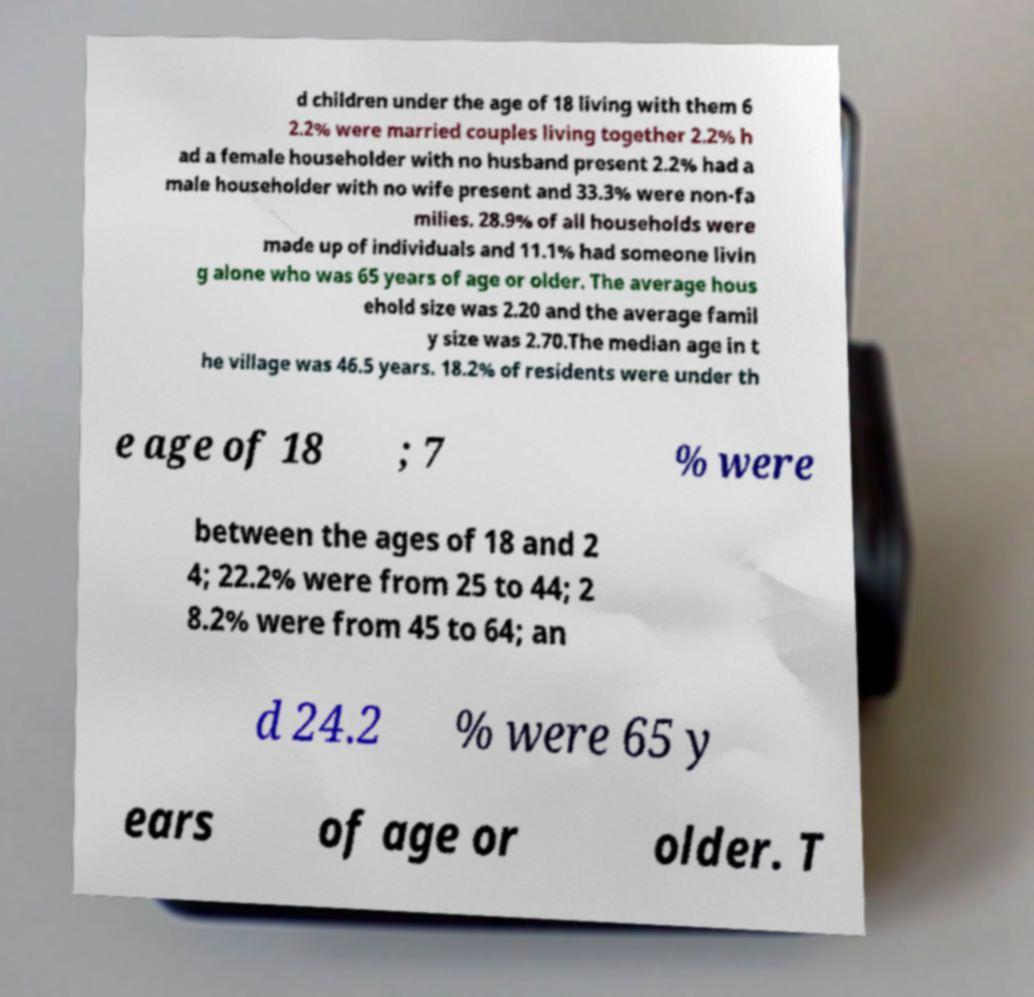What messages or text are displayed in this image? I need them in a readable, typed format. d children under the age of 18 living with them 6 2.2% were married couples living together 2.2% h ad a female householder with no husband present 2.2% had a male householder with no wife present and 33.3% were non-fa milies. 28.9% of all households were made up of individuals and 11.1% had someone livin g alone who was 65 years of age or older. The average hous ehold size was 2.20 and the average famil y size was 2.70.The median age in t he village was 46.5 years. 18.2% of residents were under th e age of 18 ; 7 % were between the ages of 18 and 2 4; 22.2% were from 25 to 44; 2 8.2% were from 45 to 64; an d 24.2 % were 65 y ears of age or older. T 